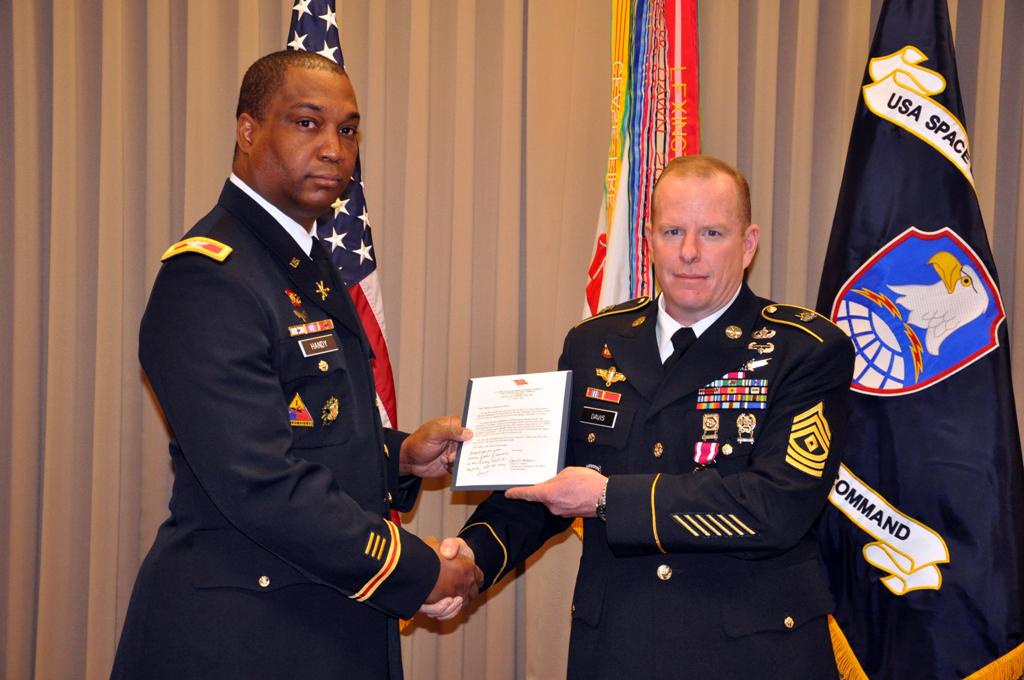What is the word on the flag at the bottom?
Your answer should be very brief. Command. 